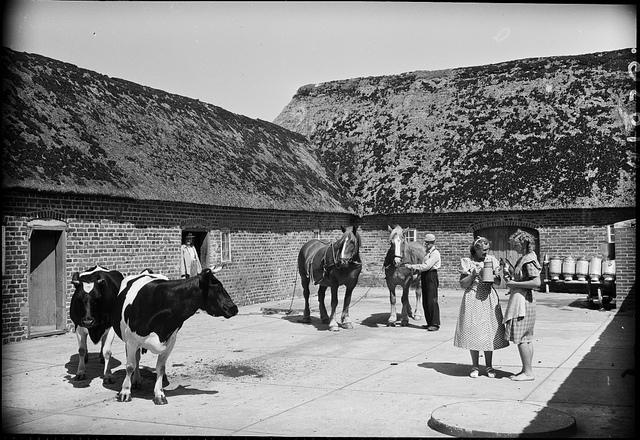Is this photo black and white?
Give a very brief answer. Yes. How many horses are there?
Be succinct. 2. What color are the cow's horns?
Give a very brief answer. White. Is the house a single story?
Write a very short answer. Yes. What are the smaller animals called?
Concise answer only. Cows. What are the buildings made of?
Short answer required. Brick. How many cows are brown?
Keep it brief. 0. What is the house's foundation made of?
Keep it brief. Brick. What color is the cow?
Answer briefly. Black and white. Is this cow okay?
Answer briefly. Yes. 